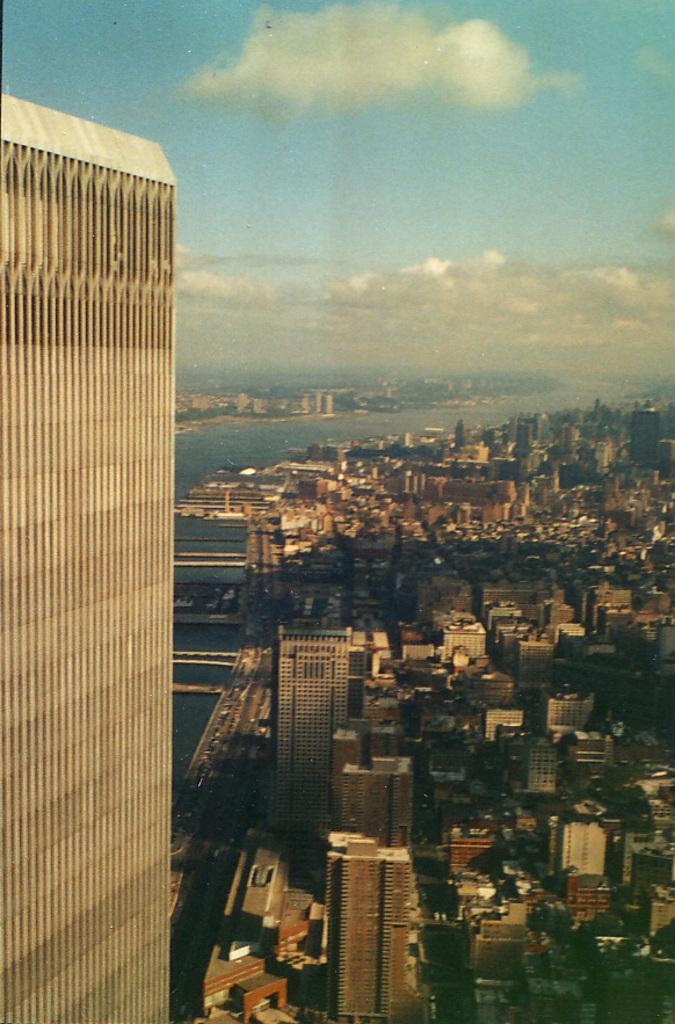What can be seen in the sky in the image? The sky is visible in the image, and there are clouds present. What natural feature is present in the image? There is a river in the image. What type of structures can be seen in the image? There are buildings in the image. What type of vegetation is present in the image? There are trees in the image. Can you describe the appearance of one of the buildings in the image? There is a building that appears to be truncated towards the left side of the image. What type of party is happening in the image? There is no party present in the image. What smell can be detected in the image? There is no information about smells in the image. 